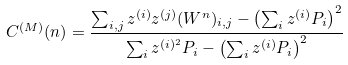Convert formula to latex. <formula><loc_0><loc_0><loc_500><loc_500>C ^ { ( M ) } ( n ) = \frac { \sum _ { i , j } z ^ { ( i ) } z ^ { ( j ) } ( W ^ { n } ) _ { i , j } - \left ( { \sum _ { i } z ^ { ( i ) } P _ { i } } \right ) ^ { 2 } } { \sum _ { i } z ^ { ( i ) ^ { 2 } } P _ { i } - \left ( { \sum _ { i } z ^ { ( i ) } P _ { i } } \right ) ^ { 2 } }</formula> 